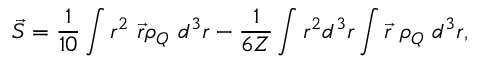<formula> <loc_0><loc_0><loc_500><loc_500>\vec { S } = \frac { 1 } { 1 0 } \int r ^ { 2 } \ \vec { r } \rho _ { Q } \ d ^ { 3 } r - \frac { 1 } { 6 Z } \int r ^ { 2 } d ^ { 3 } r \int \vec { r } \ \rho _ { Q } \ d ^ { 3 } r ,</formula> 